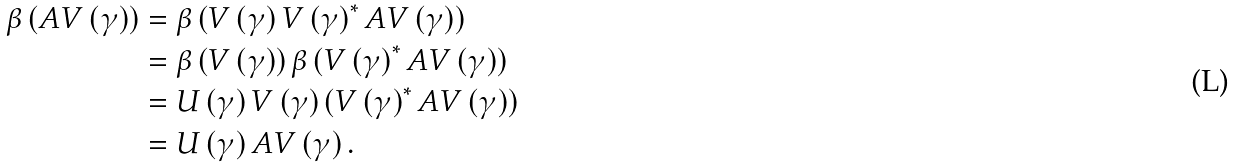<formula> <loc_0><loc_0><loc_500><loc_500>\beta \left ( A V \left ( \gamma \right ) \right ) & = \beta \left ( V \left ( \gamma \right ) V \left ( \gamma \right ) ^ { \ast } A V \left ( \gamma \right ) \right ) \\ & = \beta \left ( V \left ( \gamma \right ) \right ) \beta \left ( V \left ( \gamma \right ) ^ { \ast } A V \left ( \gamma \right ) \right ) \\ & = U \left ( \gamma \right ) V \left ( \gamma \right ) \left ( V \left ( \gamma \right ) ^ { \ast } A V \left ( \gamma \right ) \right ) \\ & = U \left ( \gamma \right ) A V \left ( \gamma \right ) .</formula> 